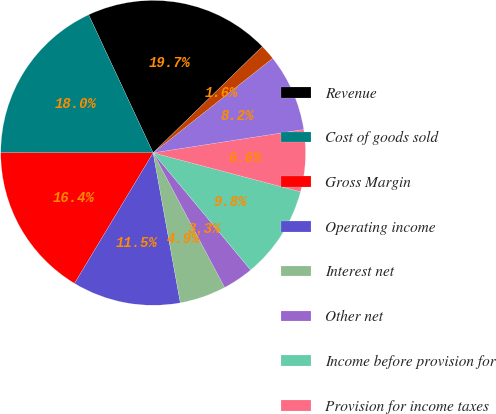Convert chart to OTSL. <chart><loc_0><loc_0><loc_500><loc_500><pie_chart><fcel>Revenue<fcel>Cost of goods sold<fcel>Gross Margin<fcel>Operating income<fcel>Interest net<fcel>Other net<fcel>Income before provision for<fcel>Provision for income taxes<fcel>Net income<fcel>Basic earnings per share<nl><fcel>19.67%<fcel>18.03%<fcel>16.39%<fcel>11.48%<fcel>4.92%<fcel>3.28%<fcel>9.84%<fcel>6.56%<fcel>8.2%<fcel>1.64%<nl></chart> 